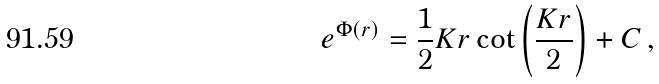Convert formula to latex. <formula><loc_0><loc_0><loc_500><loc_500>e ^ { \Phi ( r ) } = \frac { 1 } { 2 } K r \cot \left ( \frac { K r } { 2 } \right ) + C \, ,</formula> 